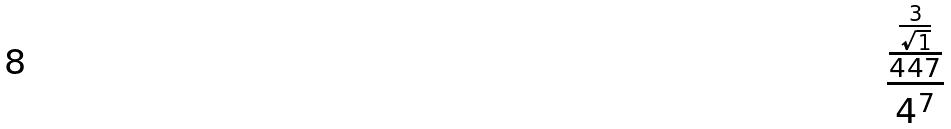Convert formula to latex. <formula><loc_0><loc_0><loc_500><loc_500>\frac { \frac { \frac { 3 } { \sqrt { 1 } } } { 4 4 7 } } { 4 ^ { 7 } }</formula> 